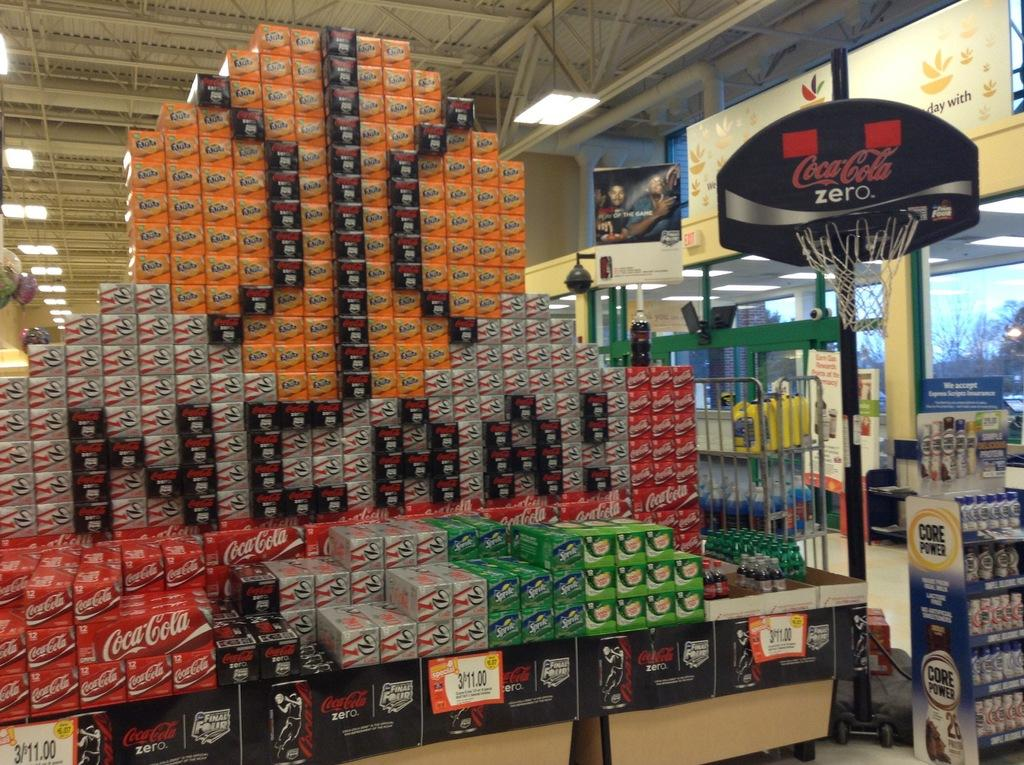<image>
Render a clear and concise summary of the photo. a Coca Cola display at a store with a basketball net reading ZERO 